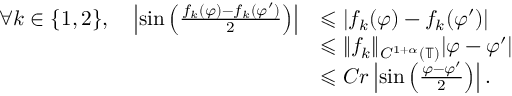<formula> <loc_0><loc_0><loc_500><loc_500>\begin{array} { r l } { \forall k \in \{ 1 , 2 \} , \quad \left | \sin \left ( \frac { f _ { k } ( \varphi ) - f _ { k } ( \varphi ^ { \prime } ) } { 2 } \right ) \right | } & { \leqslant | f _ { k } ( \varphi ) - f _ { k } ( \varphi ^ { \prime } ) | } \\ & { \leqslant \| f _ { k } \| _ { C ^ { 1 + \alpha } ( \mathbb { T } ) } | \varphi - \varphi ^ { \prime } | } \\ & { \leqslant C r \left | \sin \left ( \frac { \varphi - \varphi ^ { \prime } } { 2 } \right ) \right | . } \end{array}</formula> 